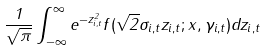Convert formula to latex. <formula><loc_0><loc_0><loc_500><loc_500>\frac { 1 } { \sqrt { \pi } } \int _ { - \infty } ^ { \infty } e ^ { - z _ { i , t } ^ { 2 } } f ( \sqrt { 2 } \sigma _ { i , t } z _ { i , t } ; x , \gamma _ { i , t } ) d z _ { i , t }</formula> 